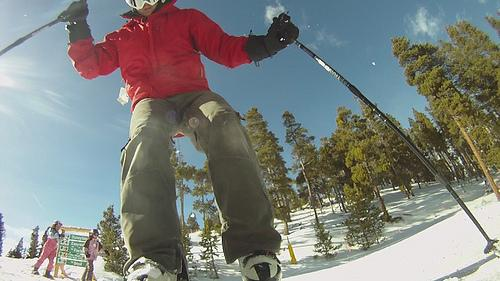Why does the person have poles? Please explain your reasoning. balance. This keeps him upright as he moves 